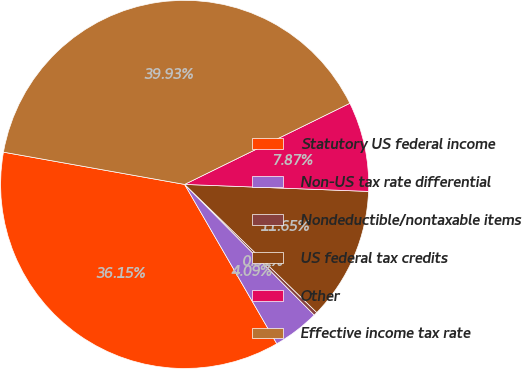Convert chart. <chart><loc_0><loc_0><loc_500><loc_500><pie_chart><fcel>Statutory US federal income<fcel>Non-US tax rate differential<fcel>Nondeductible/nontaxable items<fcel>US federal tax credits<fcel>Other<fcel>Effective income tax rate<nl><fcel>36.15%<fcel>4.09%<fcel>0.31%<fcel>11.65%<fcel>7.87%<fcel>39.93%<nl></chart> 